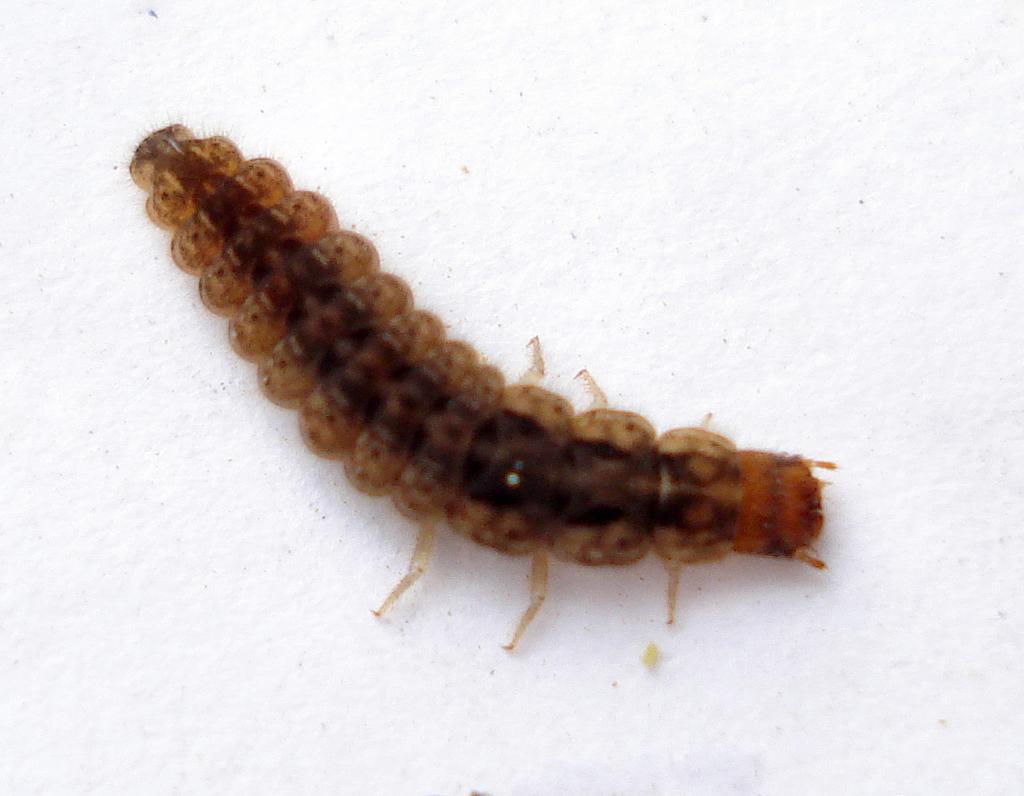Describe this image in one or two sentences. In the center of the image we can see a worm on the surface. 